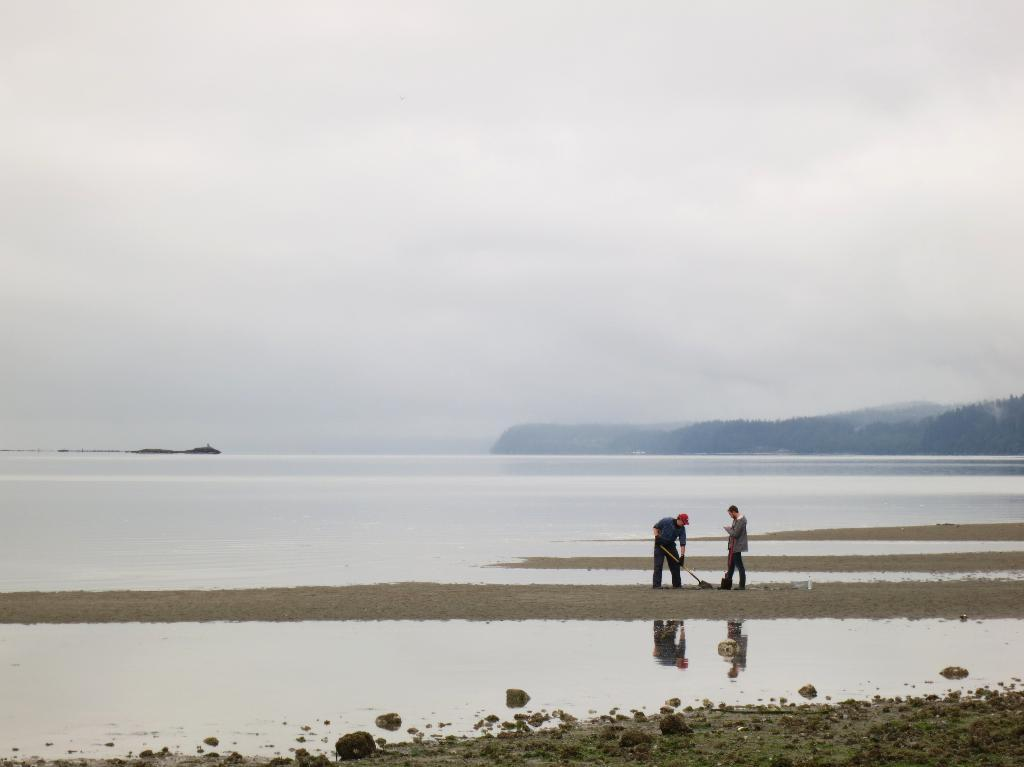What is happening on the land in the image? There are people standing on the land in the image. What can be seen in the distance behind the people? There is a sea visible in the background of the image. What type of vegetation is present in the background of the image? There are trees in the right side background of the image. What is visible above the people and the land? The sky is visible in the image. What is the condition of the sky in the image? Clouds are present in the sky. How many pizzas are being used as a connection between the people in the image? There are no pizzas present in the image; it features people standing on land with a sea, trees, and clouds in the sky. 